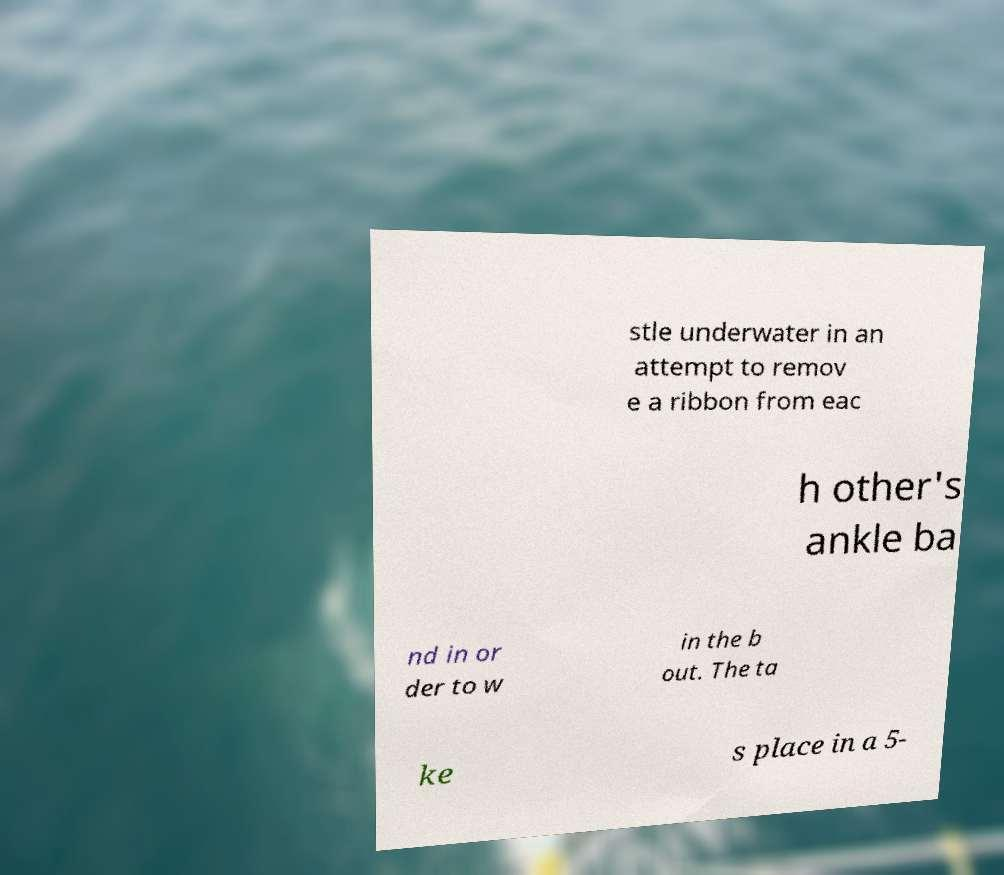There's text embedded in this image that I need extracted. Can you transcribe it verbatim? stle underwater in an attempt to remov e a ribbon from eac h other's ankle ba nd in or der to w in the b out. The ta ke s place in a 5- 